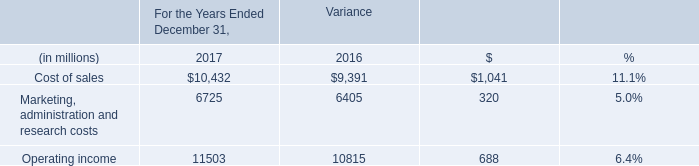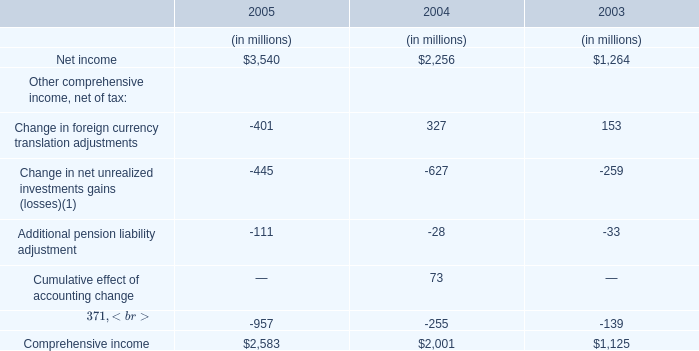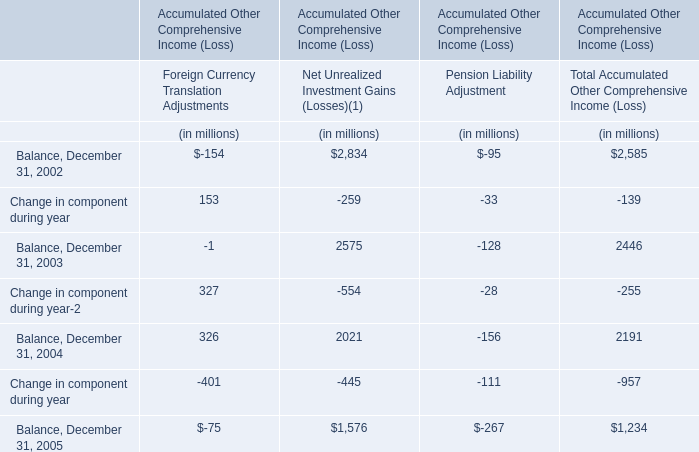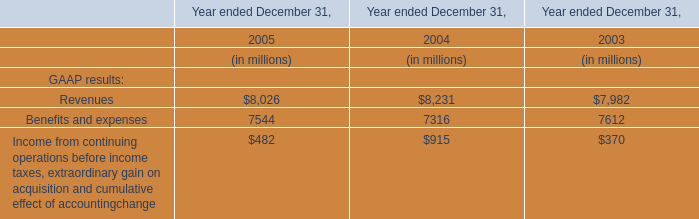In the year with the most Change in foreign currency translation adjustments, what is the growth rate of Net income? 
Computations: ((2256 - 1264) / 1264)
Answer: 0.78481. 